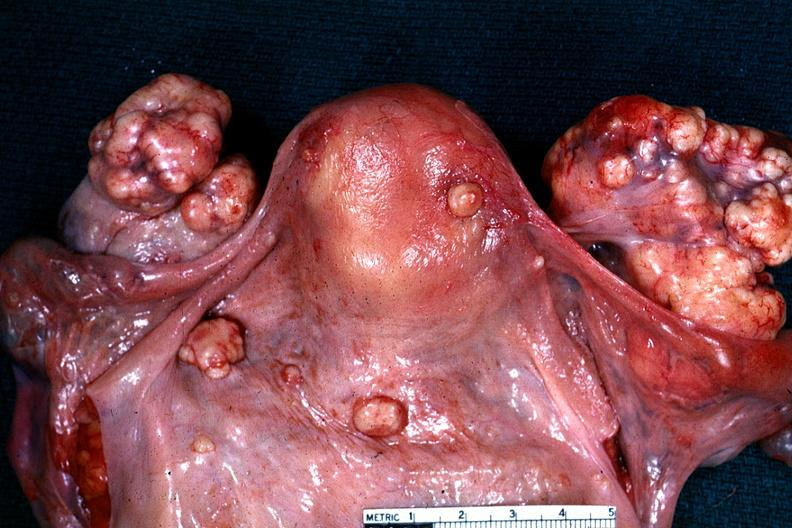what is excellent example of peritoneal carcinomatosis with implants on serosal surfaces of uterus and ovaries said?
Answer the question using a single word or phrase. To be an adenocarcinoma 